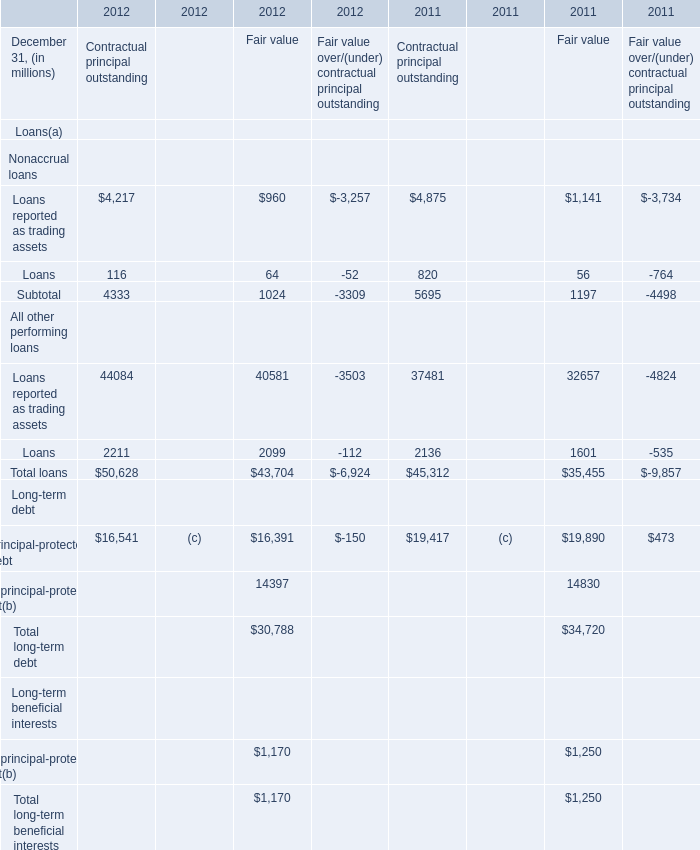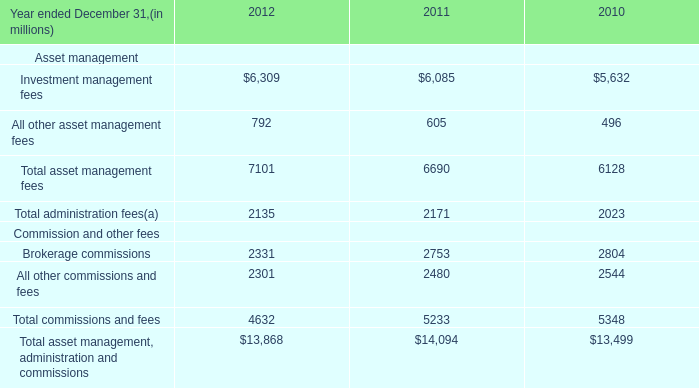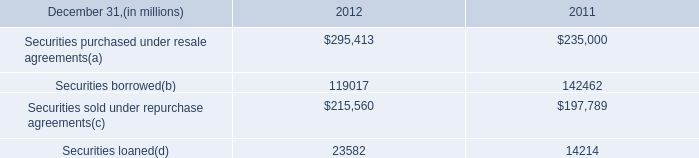What's the sum of Securities purchased under resale agreements of 2012, and Brokerage commissions Commission and other fees of 2010 ? 
Computations: (295413.0 + 2804.0)
Answer: 298217.0. 